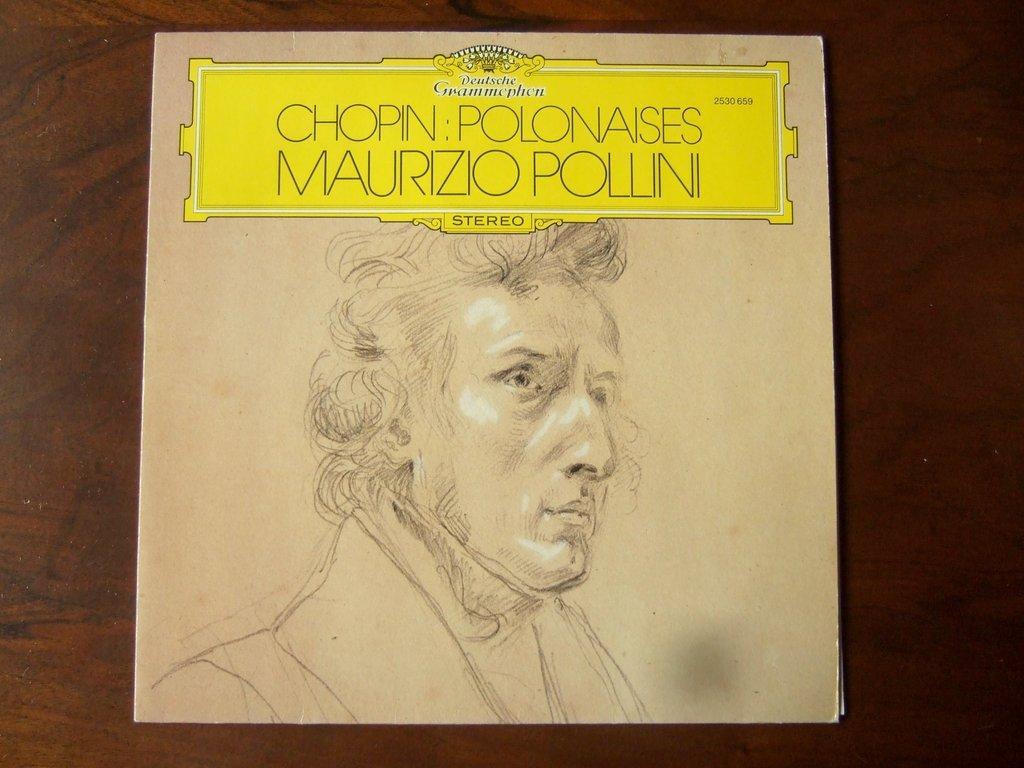Describe this image in one or two sentences. In the center of the image we can see one poster on the wooden wall. On the poster, we can see a drawing of a person and some text. 